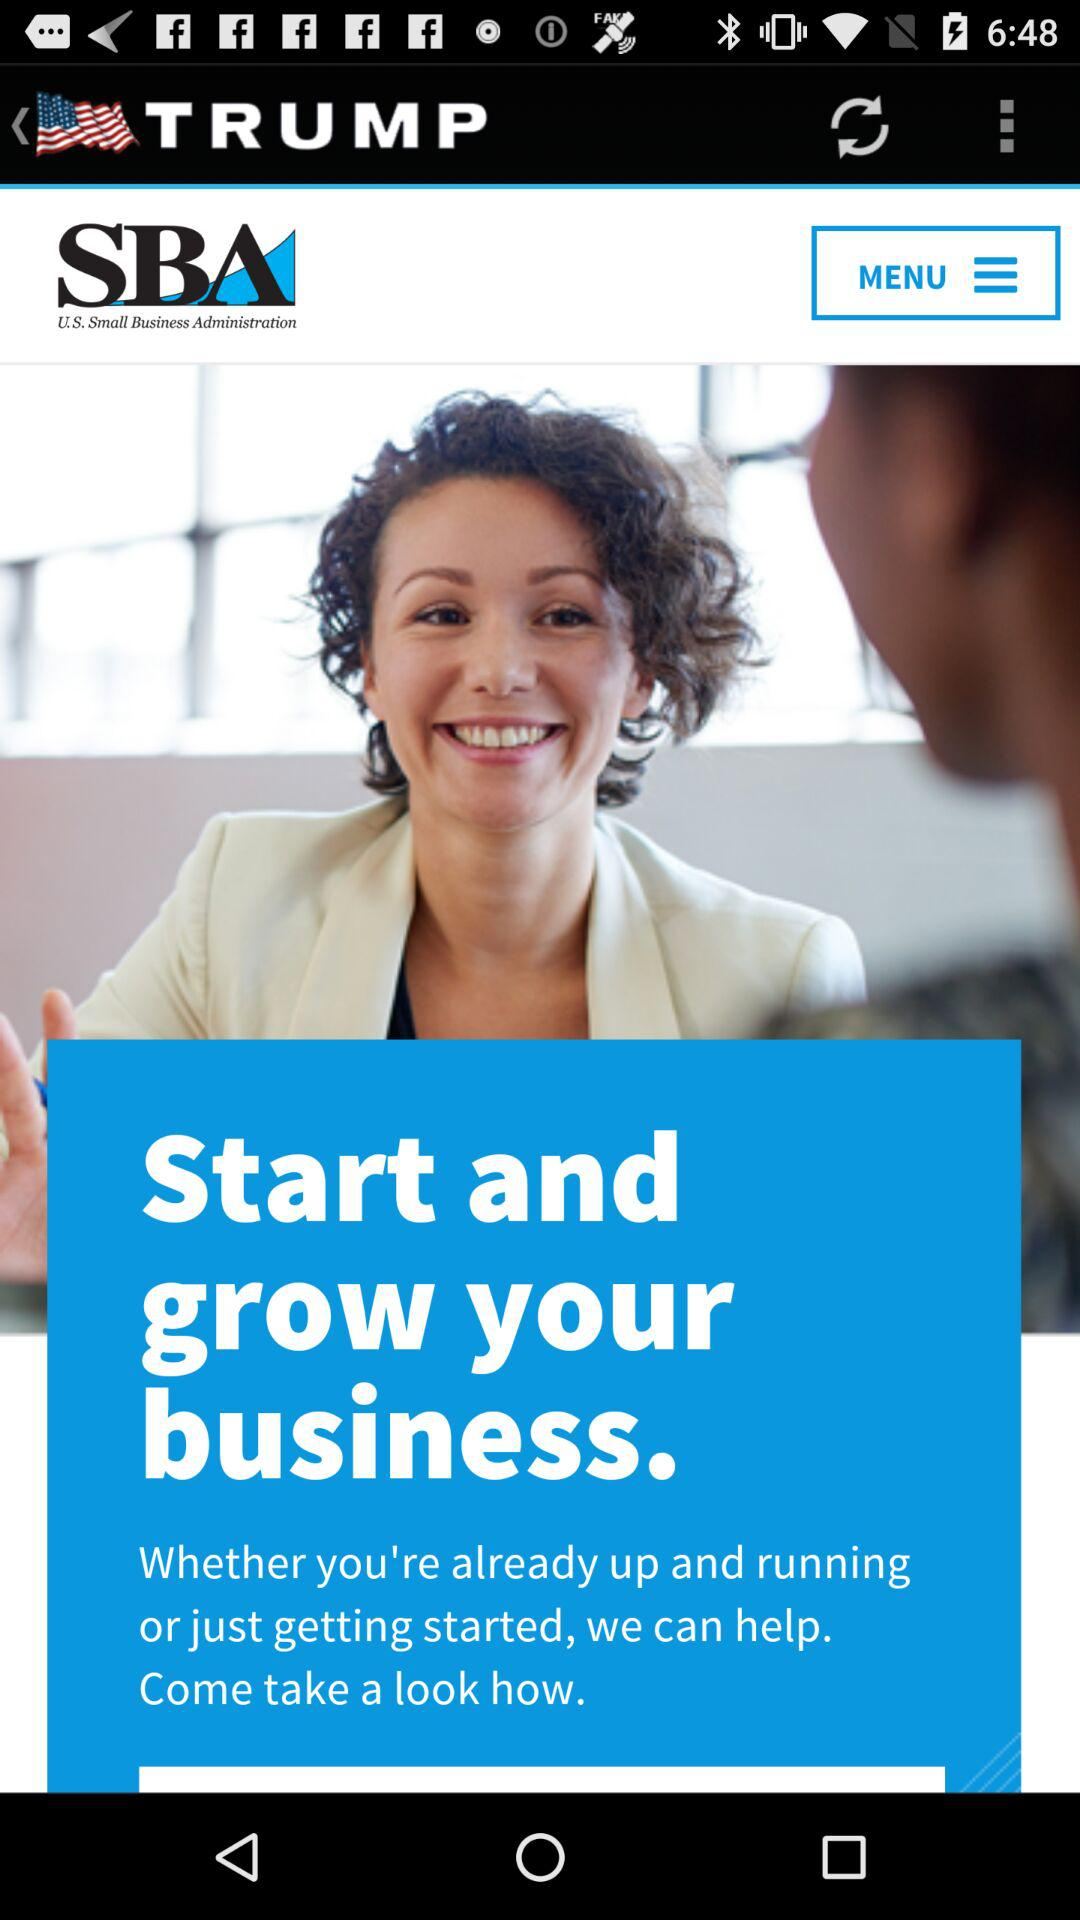What is the application Name?
When the provided information is insufficient, respond with <no answer>. <no answer> 